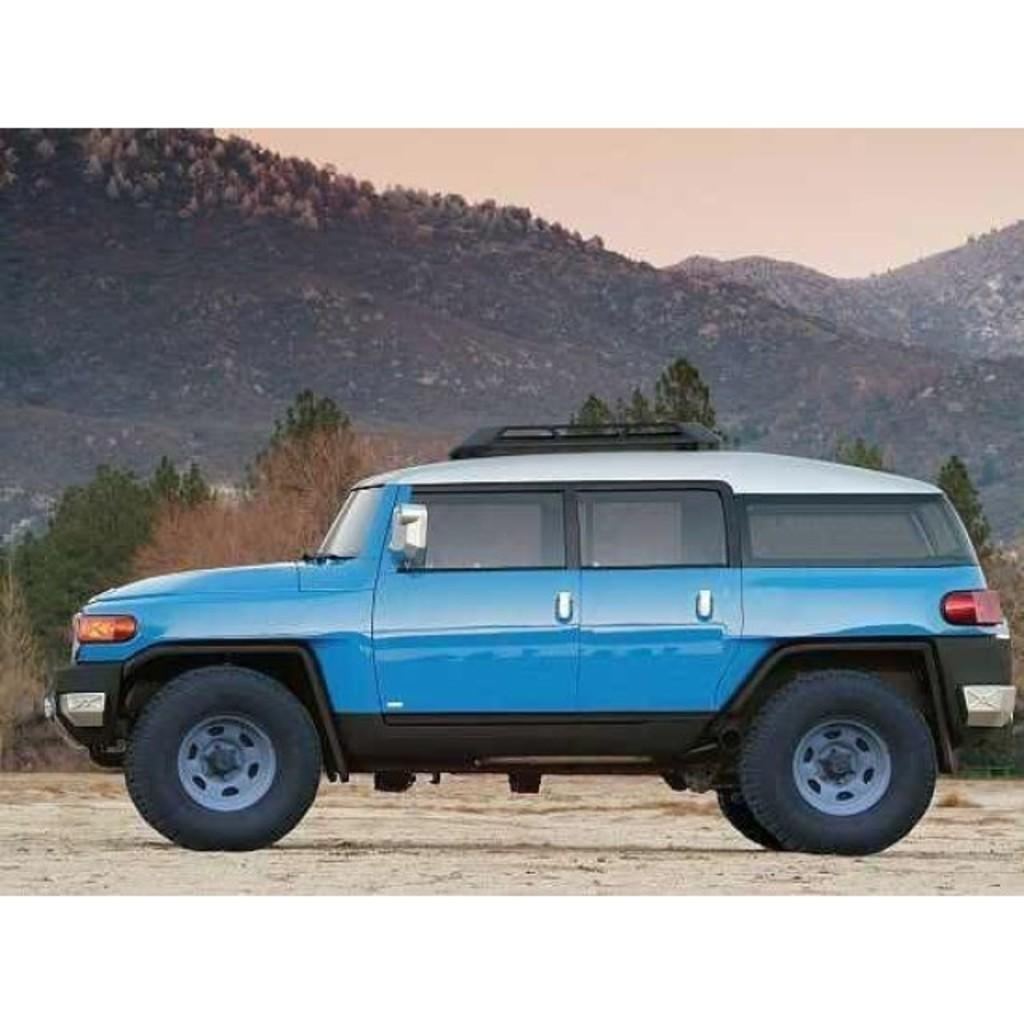What is the main subject of the image? There is a car on the road in the image. What can be seen in the background of the image? There are trees, mountains, and the sky visible in the background of the image. How many books does the writer have on the car's hood in the image? There is no writer or books present in the image; it features a car on the road with a background of trees, mountains, and the sky. 